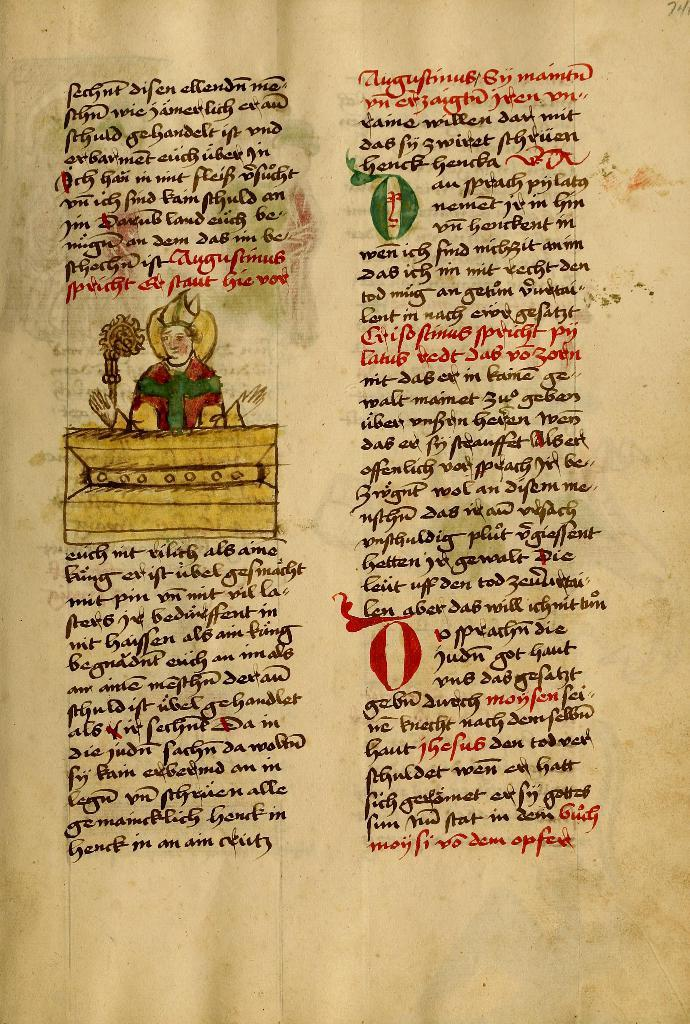What is the main object in the image? There is a paper in the image. What is the color of the paper? The paper is brown in color. What is depicted on the paper? There is an image on the paper. What else can be seen on the paper besides the image? There is text on the paper. In what language is the text written? The text is in another language. What time of day is it in the image? The time of day is not mentioned or depicted in the image. What is the name of the daughter in the image? There is no mention of a daughter or any person in the image. 